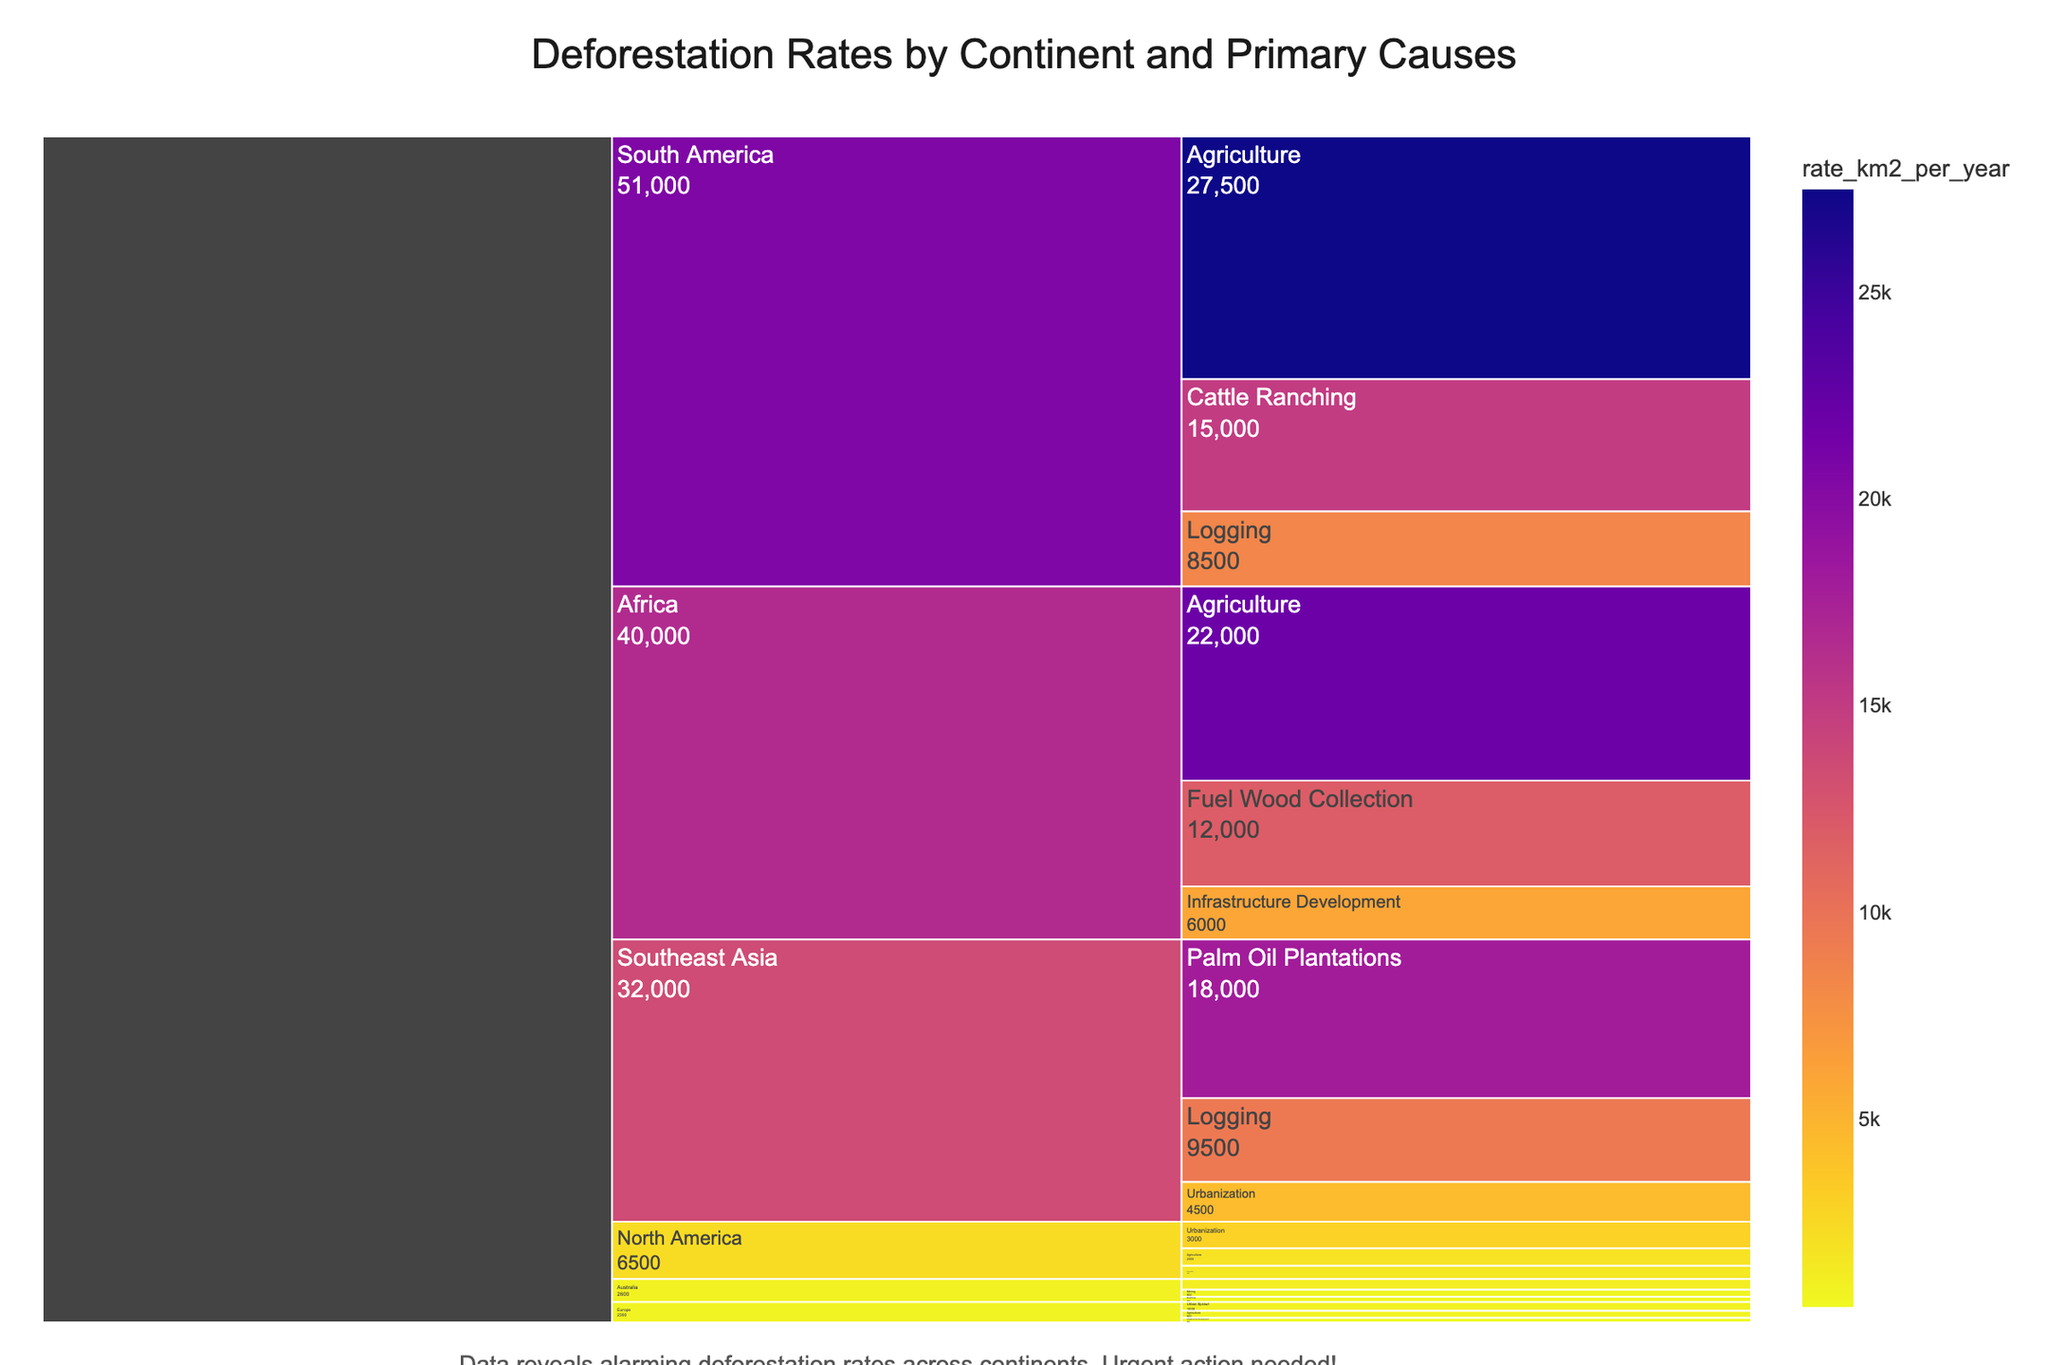What is the title of the figure? The title is displayed at the top of the figure, usually in larger font size, and is succinctly summarizing the contents of the chart. The title is 'Deforestation Rates by Continent and Primary Causes'.
Answer: Deforestation Rates by Continent and Primary Causes Which continent has the highest total deforestation rate? The icicle chart shows areas representing the total deforestation rate for each continent. The largest area, corresponding to the highest total rate, belongs to South America.
Answer: South America What is the primary cause of deforestation in South America? In the icicle chart, "South America" branches into several segments, each representing a cause. The largest segment under South America indicates the primary cause, which is Agriculture.
Answer: Agriculture How much deforestation is caused by Logging in Africa per year? By following the path from Africa to Logging in the icicle chart, you can identify the rate associated with this cause. The deforestation rate for Logging in Africa is 9,500 km² per year.
Answer: 9,500 km²/year Compare the deforestation rates due to Urbanization between Southeast Asia and North America. Which one is higher and by how much? Locate the segments for Urbanization under both continents' branches. Southeast Asia's Urbanization rate is 4,500 km²/year, and North America's is 3,000 km²/year. Subtract the lower rate from the higher one to find the difference.
Answer: Southeast Asia by 1,500 km²/year What is the total deforestation rate for Europe? Sum the deforestation rates for all causes listed under Europe's branch in the icicle chart: Urban Sprawl (1,000) + Agriculture (800) + Infrastructure Development (500).
Answer: 2,300 km²/year List the top two primary causes of deforestation in Southeast Asia and their respective rates. Identify the two largest segments under Southeast Asia in the icicle chart. The top two causes are Palm Oil Plantations (18,000 km²/year) and Logging (9,500 km²/year).
Answer: Palm Oil Plantations (18,000), Logging (9,500) Which continent has the lowest total deforestation rate, and what is it? Compare the areas representing each continent's total deforestation rate. The smallest area indicates the lowest total rate, which belongs to Europe. Sum the rates as done previously to find the total deforestation rate for Europe: 2,300 km²/year.
Answer: Europe, 2,300 km²/year What is the combined rate of deforestation due to Agriculture across all continents? Add the deforestation rates for Agriculture from all continents: South America (27,500) + Africa (22,000) + North America (2,000) + Europe (800) + Australia (1,200).
Answer: 53,500 km²/year Illustrate an example of a continent experiencing significant deforestation due to both natural and human causes. South America is undergoing significant deforestation due to human causes like Agriculture (27,500 km²/year) and natural causes like Forest Fires in North America (1,500 km²/year). This indicates that continents like North America have mixed factors.
Answer: South America and North America 